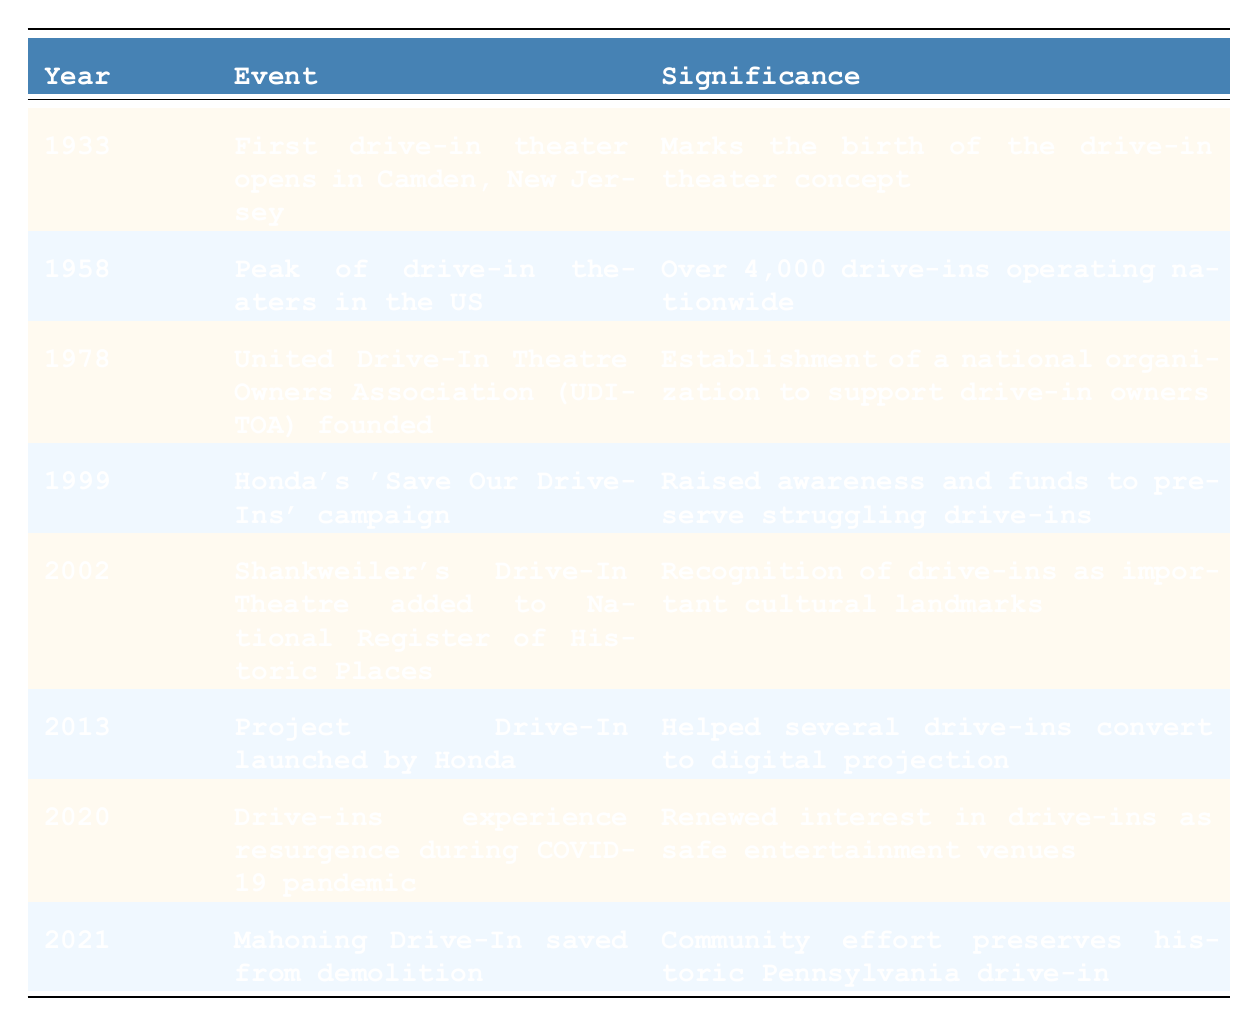What year did the first drive-in theater open? The table lists the year in the first row under the Year column, which shows "1933". This corresponds to the event in the same row about the first drive-in theater opening in Camden, New Jersey.
Answer: 1933 What significant event occurred in 1978? Looking at the Year column, the year "1978" corresponds to the founding of the United Drive-In Theatre Owners Association (UDITOA). This event is mentioned in the Event column.
Answer: United Drive-In Theatre Owners Association (UDITOA) founded How many drive-ins were operating in 1958? The table states that in "1958", there were "Over 4,000 drive-ins operating nationwide." This is clearly outlined in the Significance column corresponding to that year.
Answer: Over 4,000 Did Honda launch a campaign in 1999 to save drive-ins? The table confirms this by listing "Honda's 'Save Our Drive-Ins' campaign" in the Event column for the year "1999", indicating the answer is yes.
Answer: Yes What is the significance of Shankweiler's Drive-In Theatre's recognition in 2002? The table highlights that in "2002", Shankweiler's Drive-In Theatre was "added to National Register of Historic Places", emphasizing its importance as a cultural landmark.
Answer: Recognition as important cultural landmarks In which years were there efforts to preserve drive-ins? The table shows preservation efforts in "1999" with Honda's campaign, "2002" with Shankweiler's recognition, and "2021" when Mahoning Drive-In was saved. These three years all involve preservation initiatives as noted in the significance descriptions.
Answer: 1999, 2002, 2021 What was the nature of the resurgence for drive-ins mentioned in 2020? In "2020", the table states that drive-ins experienced a resurgence during the COVID-19 pandemic, relating to renewed interest as safe entertainment venues. The explanation is provided clearly in the Significance column for that year.
Answer: Renewed interest as safe entertainment venues Which event had the earliest occurrence according to the table? By looking through the Year column, the earliest year listed is "1933", which corresponds to the opening of the first drive-in theater. Thus, it’s the earliest significant event in the timeline.
Answer: First drive-in theater opens in Camden, New Jersey How many years are listed in the table? Counting the rows under 'Year', there are eight distinct years listed from "1933" to "2021". Thus, the total number of years is eight since each row represents one significant event on the timeline.
Answer: 8 